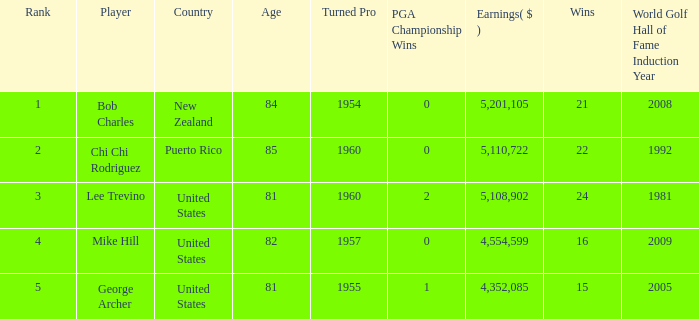On average, how many wins have a rank lower than 1? None. 